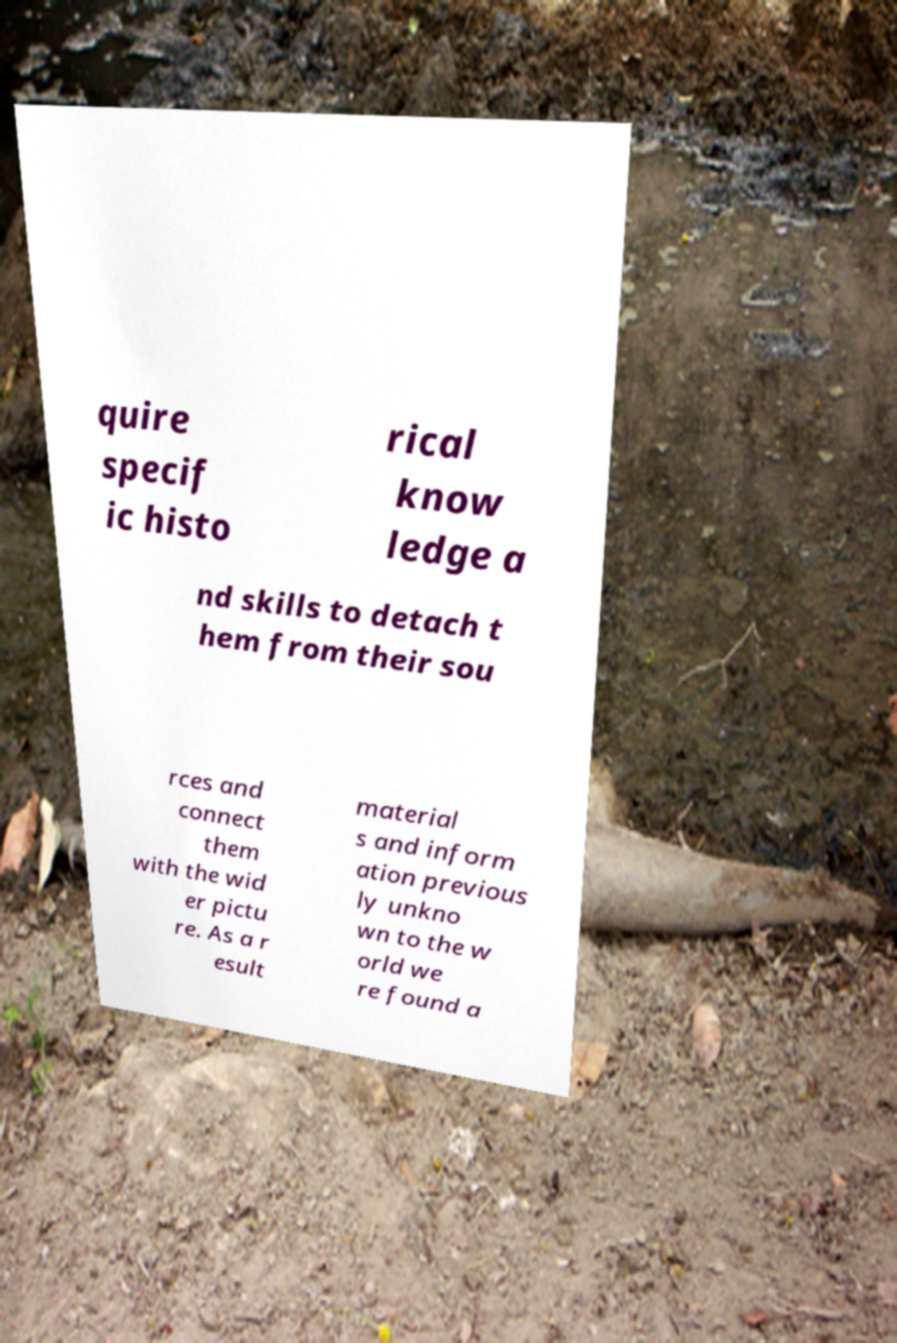Can you read and provide the text displayed in the image?This photo seems to have some interesting text. Can you extract and type it out for me? quire specif ic histo rical know ledge a nd skills to detach t hem from their sou rces and connect them with the wid er pictu re. As a r esult material s and inform ation previous ly unkno wn to the w orld we re found a 